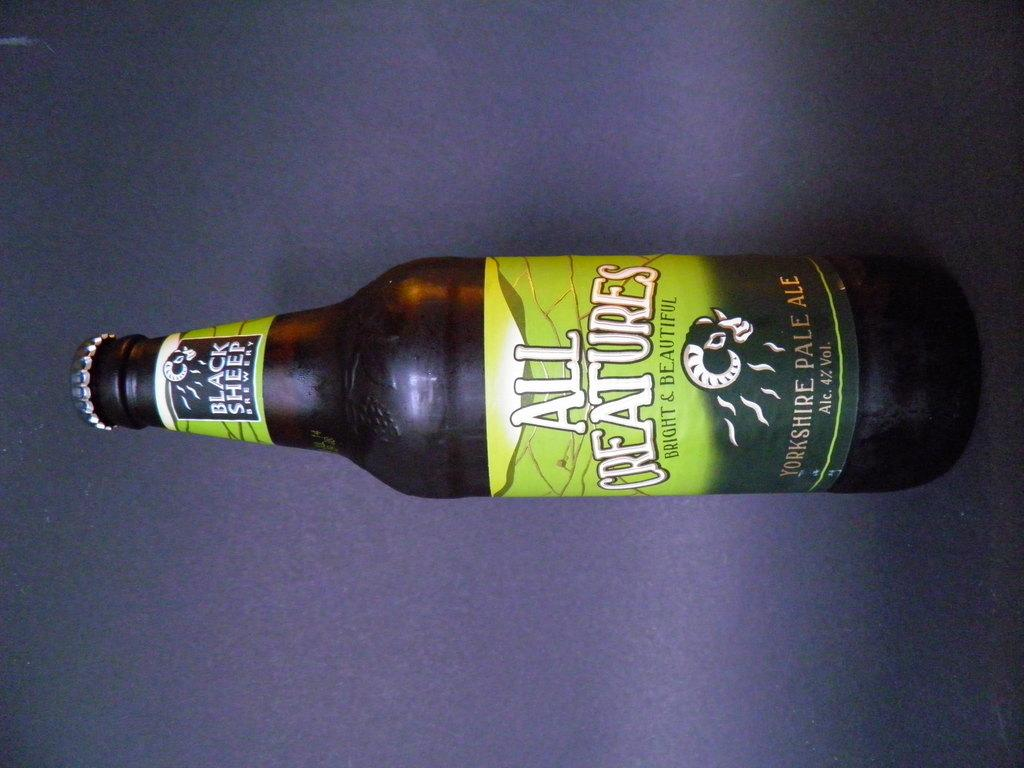<image>
Render a clear and concise summary of the photo. All Creatures beer placed in front of a purple background. 